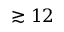Convert formula to latex. <formula><loc_0><loc_0><loc_500><loc_500>\gtrsim 1 2</formula> 